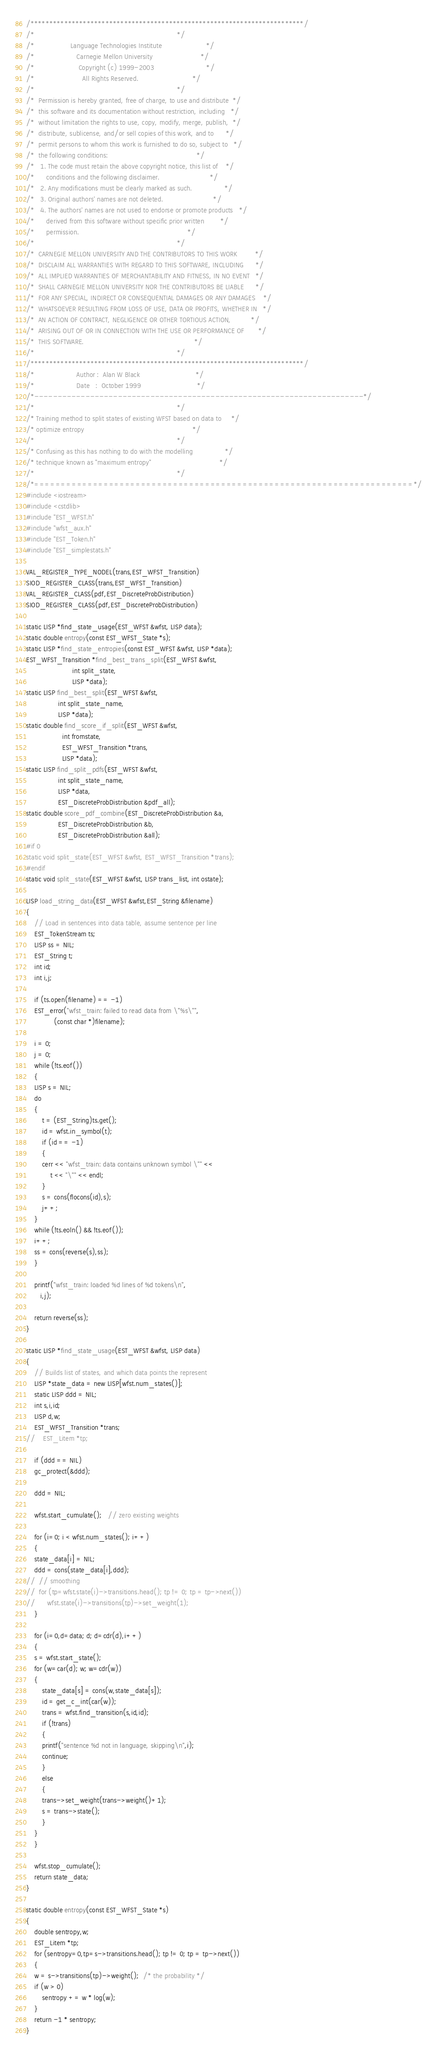Convert code to text. <code><loc_0><loc_0><loc_500><loc_500><_C++_>/*************************************************************************/
/*                                                                       */
/*                  Language Technologies Institute                      */
/*                     Carnegie Mellon University                        */
/*                      Copyright (c) 1999-2003                          */
/*                        All Rights Reserved.                           */
/*                                                                       */
/*  Permission is hereby granted, free of charge, to use and distribute  */
/*  this software and its documentation without restriction, including   */
/*  without limitation the rights to use, copy, modify, merge, publish,  */
/*  distribute, sublicense, and/or sell copies of this work, and to      */
/*  permit persons to whom this work is furnished to do so, subject to   */
/*  the following conditions:                                            */
/*   1. The code must retain the above copyright notice, this list of    */
/*      conditions and the following disclaimer.                         */
/*   2. Any modifications must be clearly marked as such.                */
/*   3. Original authors' names are not deleted.                         */
/*   4. The authors' names are not used to endorse or promote products   */
/*      derived from this software without specific prior written        */
/*      permission.                                                      */
/*                                                                       */
/*  CARNEGIE MELLON UNIVERSITY AND THE CONTRIBUTORS TO THIS WORK         */
/*  DISCLAIM ALL WARRANTIES WITH REGARD TO THIS SOFTWARE, INCLUDING      */
/*  ALL IMPLIED WARRANTIES OF MERCHANTABILITY AND FITNESS, IN NO EVENT   */
/*  SHALL CARNEGIE MELLON UNIVERSITY NOR THE CONTRIBUTORS BE LIABLE      */
/*  FOR ANY SPECIAL, INDIRECT OR CONSEQUENTIAL DAMAGES OR ANY DAMAGES    */
/*  WHATSOEVER RESULTING FROM LOSS OF USE, DATA OR PROFITS, WHETHER IN   */
/*  AN ACTION OF CONTRACT, NEGLIGENCE OR OTHER TORTIOUS ACTION,          */
/*  ARISING OUT OF OR IN CONNECTION WITH THE USE OR PERFORMANCE OF       */
/*  THIS SOFTWARE.                                                       */
/*                                                                       */
/*************************************************************************/
/*                     Author :  Alan W Black                            */
/*                     Date   :  October 1999                            */
/*-----------------------------------------------------------------------*/
/*                                                                       */
/* Training method to split states of existing WFST based on data to     */
/* optimize entropy                                                      */
/*                                                                       */
/* Confusing as this has nothing to do with the modelling                */
/* technique known as "maximum entropy"                                  */
/*                                                                       */
/*=======================================================================*/
#include <iostream>
#include <cstdlib>
#include "EST_WFST.h"
#include "wfst_aux.h"
#include "EST_Token.h"
#include "EST_simplestats.h"

VAL_REGISTER_TYPE_NODEL(trans,EST_WFST_Transition)
SIOD_REGISTER_CLASS(trans,EST_WFST_Transition)
VAL_REGISTER_CLASS(pdf,EST_DiscreteProbDistribution)
SIOD_REGISTER_CLASS(pdf,EST_DiscreteProbDistribution)

static LISP *find_state_usage(EST_WFST &wfst, LISP data);
static double entropy(const EST_WFST_State *s);
static LISP *find_state_entropies(const EST_WFST &wfst, LISP *data);
EST_WFST_Transition *find_best_trans_split(EST_WFST &wfst,
					   int split_state,
					   LISP *data);
static LISP find_best_split(EST_WFST &wfst,	
			    int split_state_name,
			    LISP *data);
static double find_score_if_split(EST_WFST &wfst,
				  int fromstate,
				  EST_WFST_Transition *trans,
				  LISP *data);
static LISP find_split_pdfs(EST_WFST &wfst,
			    int split_state_name,
			    LISP *data,
			    EST_DiscreteProbDistribution &pdf_all);
static double score_pdf_combine(EST_DiscreteProbDistribution &a,
				EST_DiscreteProbDistribution &b,
				EST_DiscreteProbDistribution &all);
#if 0
static void split_state(EST_WFST &wfst, EST_WFST_Transition *trans);
#endif
static void split_state(EST_WFST &wfst, LISP trans_list, int ostate);

LISP load_string_data(EST_WFST &wfst,EST_String &filename)
{
    // Load in sentences into data table, assume sentence per line
    EST_TokenStream ts;
    LISP ss = NIL;
    EST_String t;
    int id;
    int i,j;
    
    if (ts.open(filename) == -1)
	EST_error("wfst_train: failed to read data from \"%s\"",
			  (const char *)filename);

    i = 0;
    j = 0;
    while (!ts.eof())
    {
	LISP s = NIL;
	do
	{
	    t = (EST_String)ts.get();
	    id = wfst.in_symbol(t);
	    if (id == -1)
	    {
		cerr << "wfst_train: data contains unknown symbol \"" <<
		    t << "\"" << endl;
	    }
	    s = cons(flocons(id),s);
	    j++;
	}
	while (!ts.eoln() && !ts.eof());
	i++;
	ss = cons(reverse(s),ss);
    }

    printf("wfst_train: loaded %d lines of %d tokens\n",
	   i,j);

    return reverse(ss);
}

static LISP *find_state_usage(EST_WFST &wfst, LISP data)
{
    // Builds list of states, and which data points the represent
    LISP *state_data = new LISP[wfst.num_states()];
    static LISP ddd = NIL;
    int s,i,id;
    LISP d,w;
    EST_WFST_Transition *trans;
//    EST_Litem *tp;

    if (ddd == NIL)
	gc_protect(&ddd);

    ddd = NIL;

    wfst.start_cumulate();   // zero existing weights

    for (i=0; i < wfst.num_states(); i++)
    {
	state_data[i] = NIL;
	ddd = cons(state_data[i],ddd);
//	// smoothing
//	for (tp=wfst.state(i)->transitions.head(); tp != 0; tp = tp->next())
//	    wfst.state(i)->transitions(tp)->set_weight(1);
    }

    for (i=0,d=data; d; d=cdr(d),i++)
    {
	s = wfst.start_state();
	for (w=car(d); w; w=cdr(w))
	{
	    state_data[s] = cons(w,state_data[s]);
	    id = get_c_int(car(w));
	    trans = wfst.find_transition(s,id,id);
	    if (!trans)
	    {
		printf("sentence %d not in language, skipping\n",i);
		continue;
	    }
	    else
	    {
		trans->set_weight(trans->weight()+1);
		s = trans->state();
	    }
	}
    }
	
    wfst.stop_cumulate();
    return state_data;
}

static double entropy(const EST_WFST_State *s)
{
    double sentropy,w;
    EST_Litem *tp;
    for (sentropy=0,tp=s->transitions.head(); tp != 0; tp = tp->next())
    {
	w = s->transitions(tp)->weight();  /* the probability */
	if (w > 0)
	    sentropy += w * log(w);
    }
    return -1 * sentropy;
}
</code> 